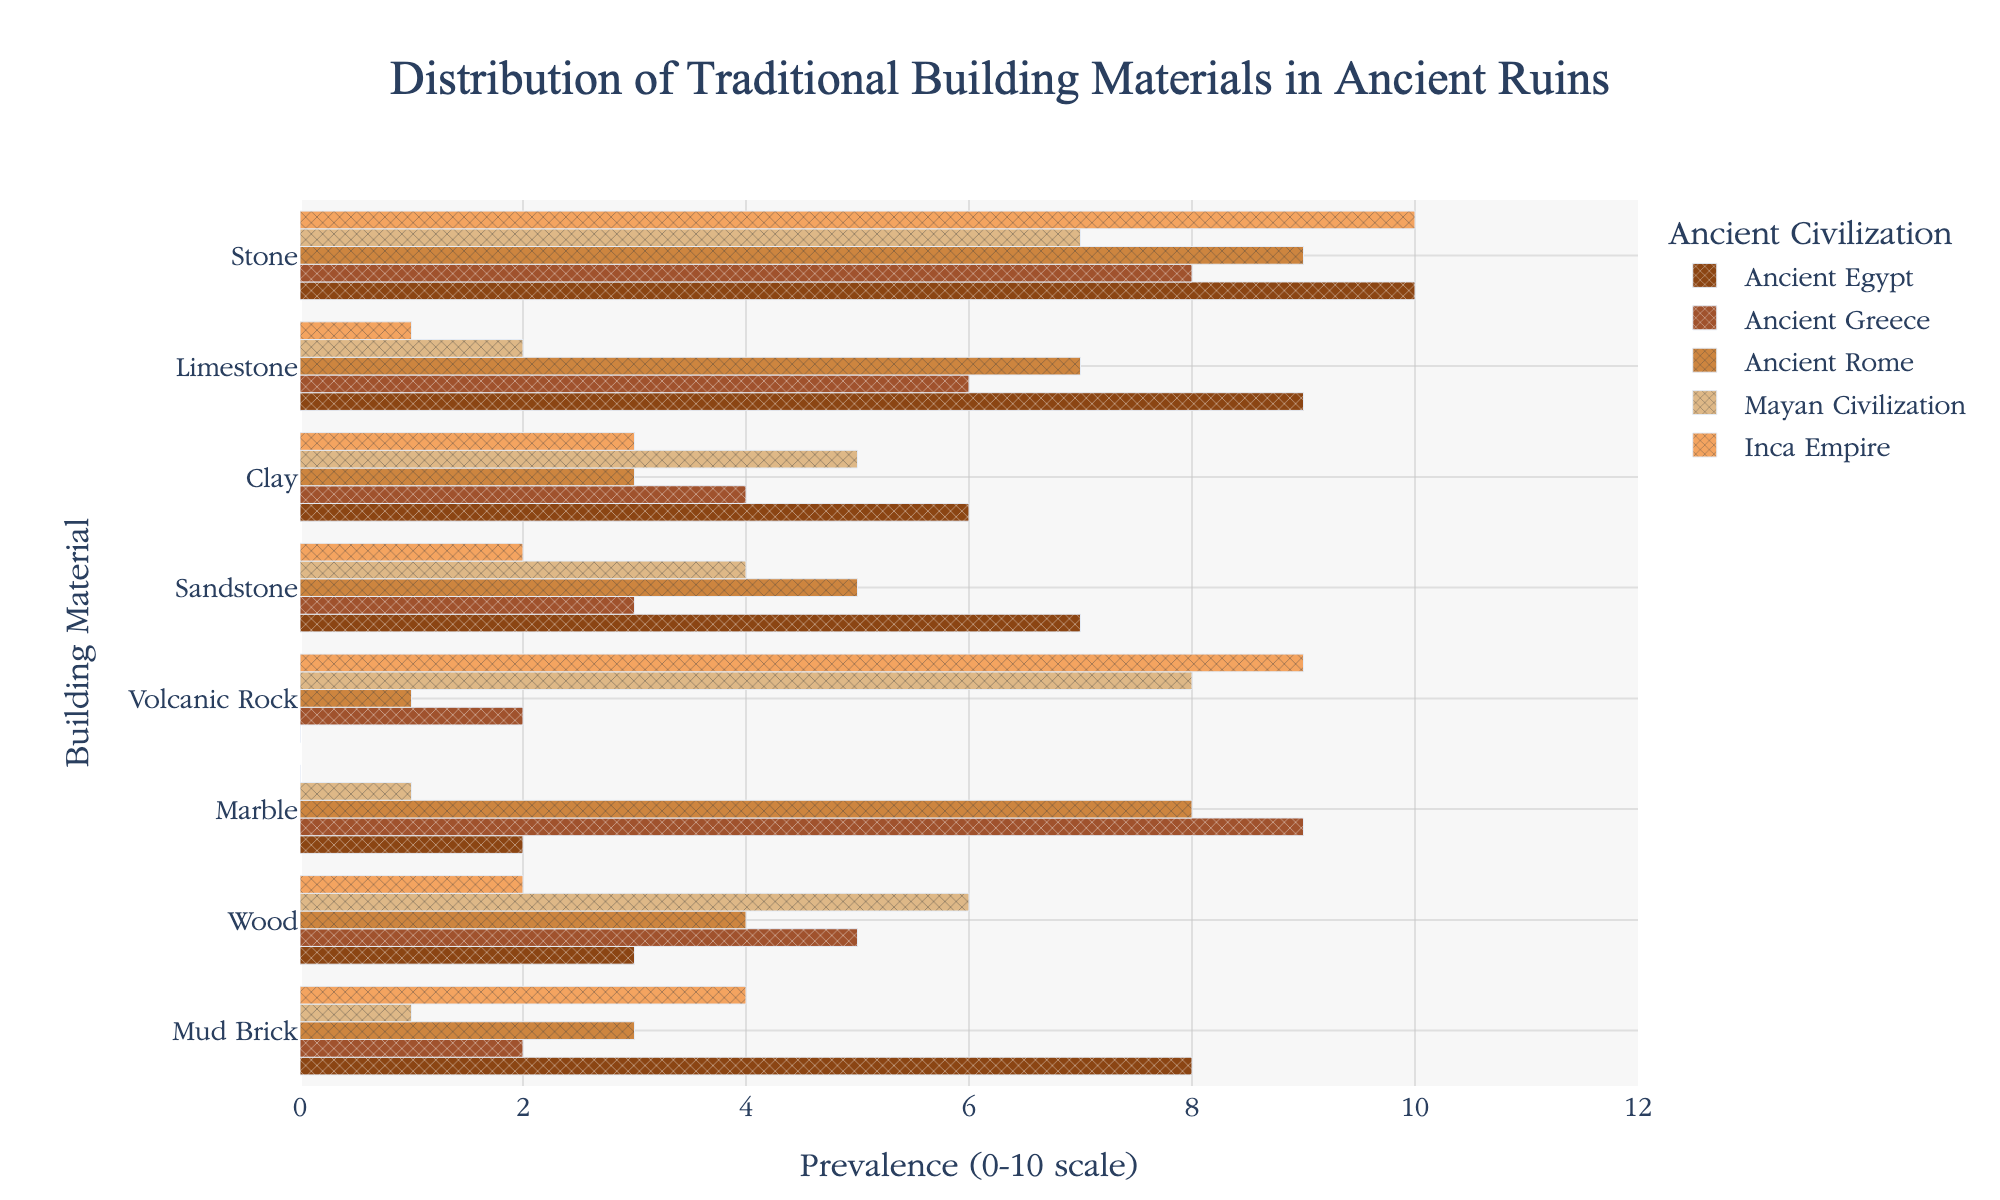Which civilization used the most stone in their construction? By observing the highest value bar for the "Stone" material, we can see that Ancient Egypt and the Inca Empire both have a value of 10. Thus, both civilizations used the most stone.
Answer: Ancient Egypt and Inca Empire Which building material was most predominant in Ancient Greece? Looking at the highest bar under the Ancient Greece section, Marble has a value of 9, which is the highest. This indicates Marble was most commonly used.
Answer: Marble How does the use of mud brick compare between the Mayan Civilization and the Inca Empire? The bar for Mud Brick shows a value of 1 for the Mayan Civilization and 4 for the Inca Empire. By comparing these values, Mud Brick was used more in the Inca Empire.
Answer: More in the Inca Empire What is the total prevalence of Sandstone use across all civilizations? By summing up the values for Sandstone in all civilizations: 7 (Ancient Egypt) + 3 (Ancient Greece) + 5 (Ancient Rome) + 4 (Mayan Civilization) + 2 (Inca Empire), the total prevalence is 21.
Answer: 21 Which civilization has the least diverse set of building materials (i.e., the fewest different materials used)? Looking at the number of non-zero values for each civilization: 
- Ancient Egypt: 7 materials,
- Ancient Greece: 7 materials,
- Ancient Rome: 7 materials,
- Mayan Civilization: 7 materials,
- Inca Empire: 7 materials.
All civilizations used the same number of different materials.
Answer: All have equal diversity For which material is the use almost absent in Ancient Egypt? The bar for Volcanic Rock in Ancient Egypt shows a value of 0, indicating its use is almost absent.
Answer: Volcanic Rock What is the average prevalence of Clay use across all civilizations? Adding the values for Clay across all civilizations:
6 (Ancient Egypt) + 4 (Ancient Greece) + 3 (Ancient Rome) + 5 (Mayan Civilization) + 3 (Inca Empire) equals 21, and dividing this by 5, the number of civilizations, the average prevalence is 4.2.
Answer: 4.2 Between Ancient Rome and the Mayan Civilization, which civilization utilized Limestone more intensively? The bar for Limestone shows a value of 7 for Ancient Rome and 2 for the Mayan Civilization. Therefore, Ancient Rome utilized Limestone more intensively.
Answer: Ancient Rome Which civilization shows the most significant use of Volcanic Rock? Observing the value bars for Volcanic Rock, Mayan Civilization has a value of 8, and Inca Empire has 9. The highest value is found in the Inca Empire.
Answer: Inca Empire What is the total number of building materials used at a prevalence level of 5 or more in the Ancient Rome? Identifying the bars with values 5 or more in Ancient Rome, we count:
- Stone (9),
- Limestone (7),
- Marble (8),
- Sandstone (5).
This totals 4 materials.
Answer: 4 